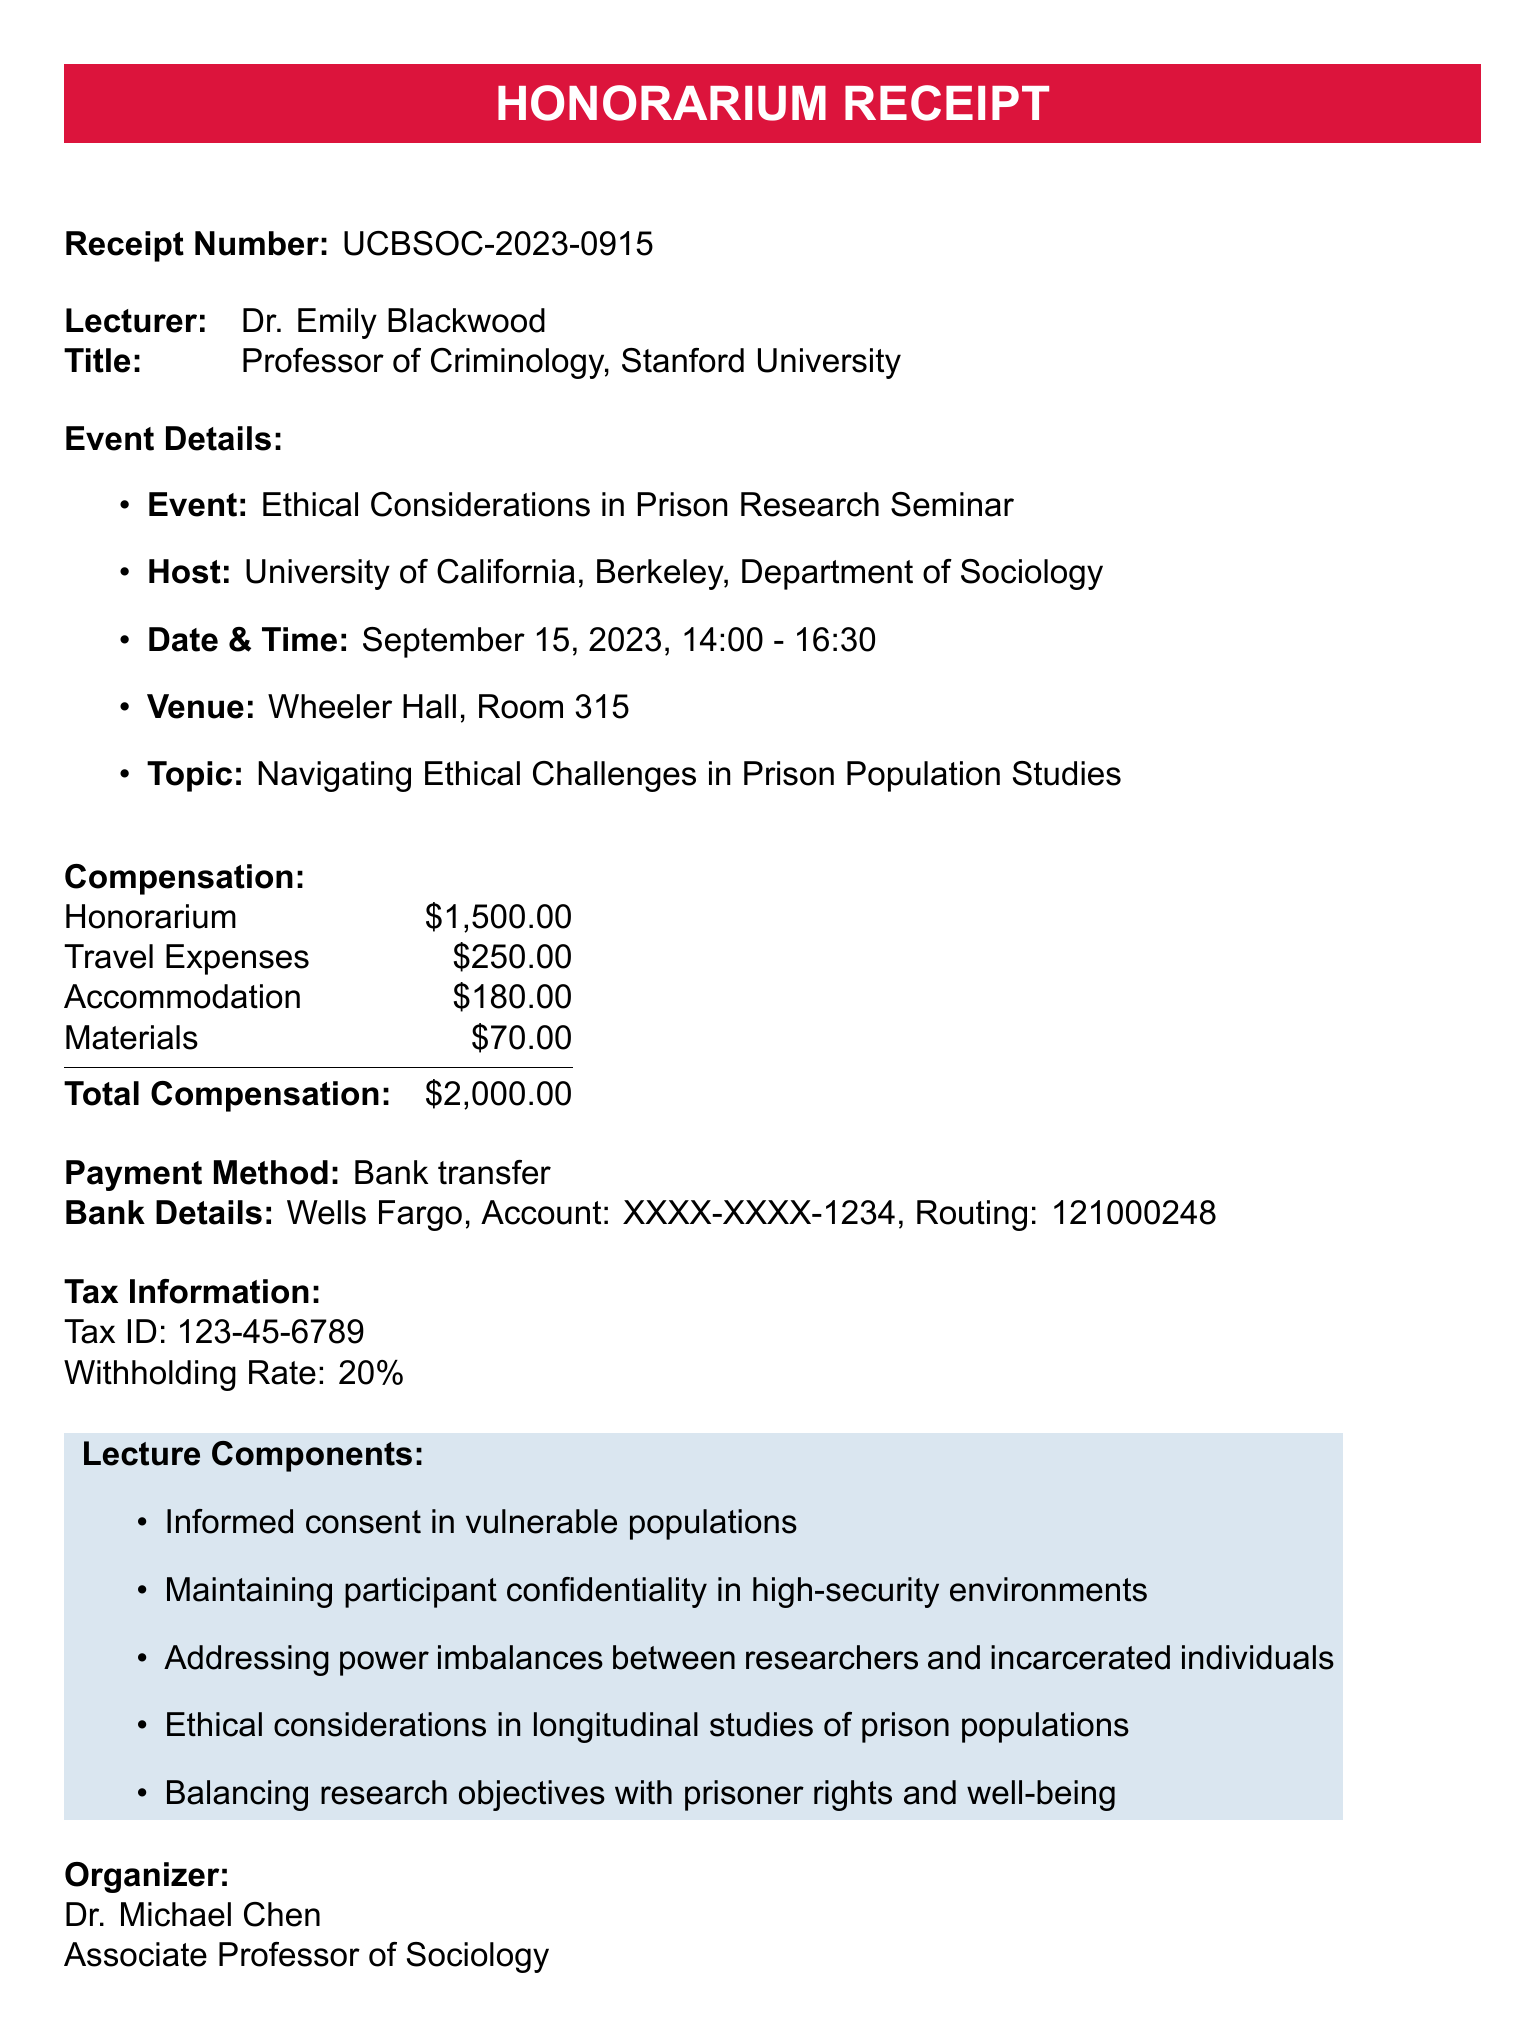What is the name of the lecturer? The lecturer is Dr. Emily Blackwood as stated in the document.
Answer: Dr. Emily Blackwood What is the total compensation amount? The total compensation is the sum of the honorarium and additional expenses, which totals $2000.
Answer: $2000 What is the date of the event? The document specifies the event date as September 15, 2023.
Answer: September 15, 2023 Who organized the seminar? The organizer's name is Dr. Michael Chen, as mentioned in the document.
Answer: Dr. Michael Chen What is the honorarium amount? The honorarium amount listed in the document is $1500.
Answer: $1500 What is the payment method? The payment method for the honorarium is stated as a bank transfer.
Answer: Bank transfer What is the lecture topic? The topic of the lecture is "Navigating Ethical Challenges in Prison Population Studies".
Answer: Navigating Ethical Challenges in Prison Population Studies How much was spent on travel expenses? The travel expenses listed in the document amount to $250.
Answer: $250 What is the withholding rate for taxes? The document states that the withholding rate is 20%.
Answer: 20% 